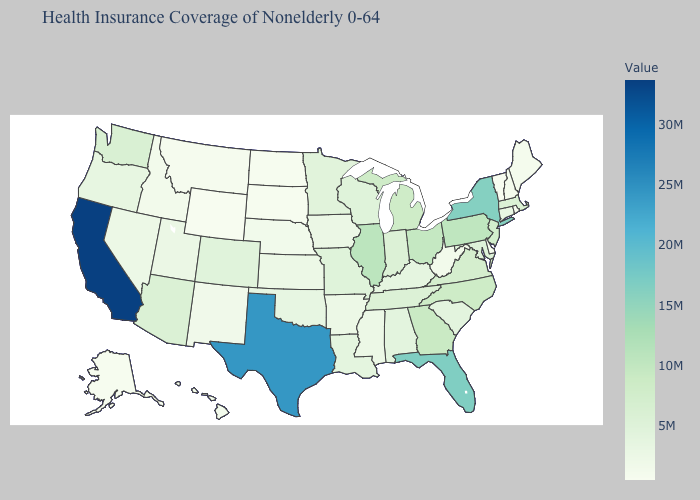Among the states that border Wyoming , does Colorado have the lowest value?
Keep it brief. No. Which states have the lowest value in the West?
Be succinct. Wyoming. Does Wisconsin have a lower value than Hawaii?
Short answer required. No. Which states hav the highest value in the MidWest?
Keep it brief. Illinois. Among the states that border Pennsylvania , does Delaware have the highest value?
Keep it brief. No. Does North Dakota have the lowest value in the MidWest?
Keep it brief. Yes. Does Rhode Island have the highest value in the Northeast?
Answer briefly. No. 